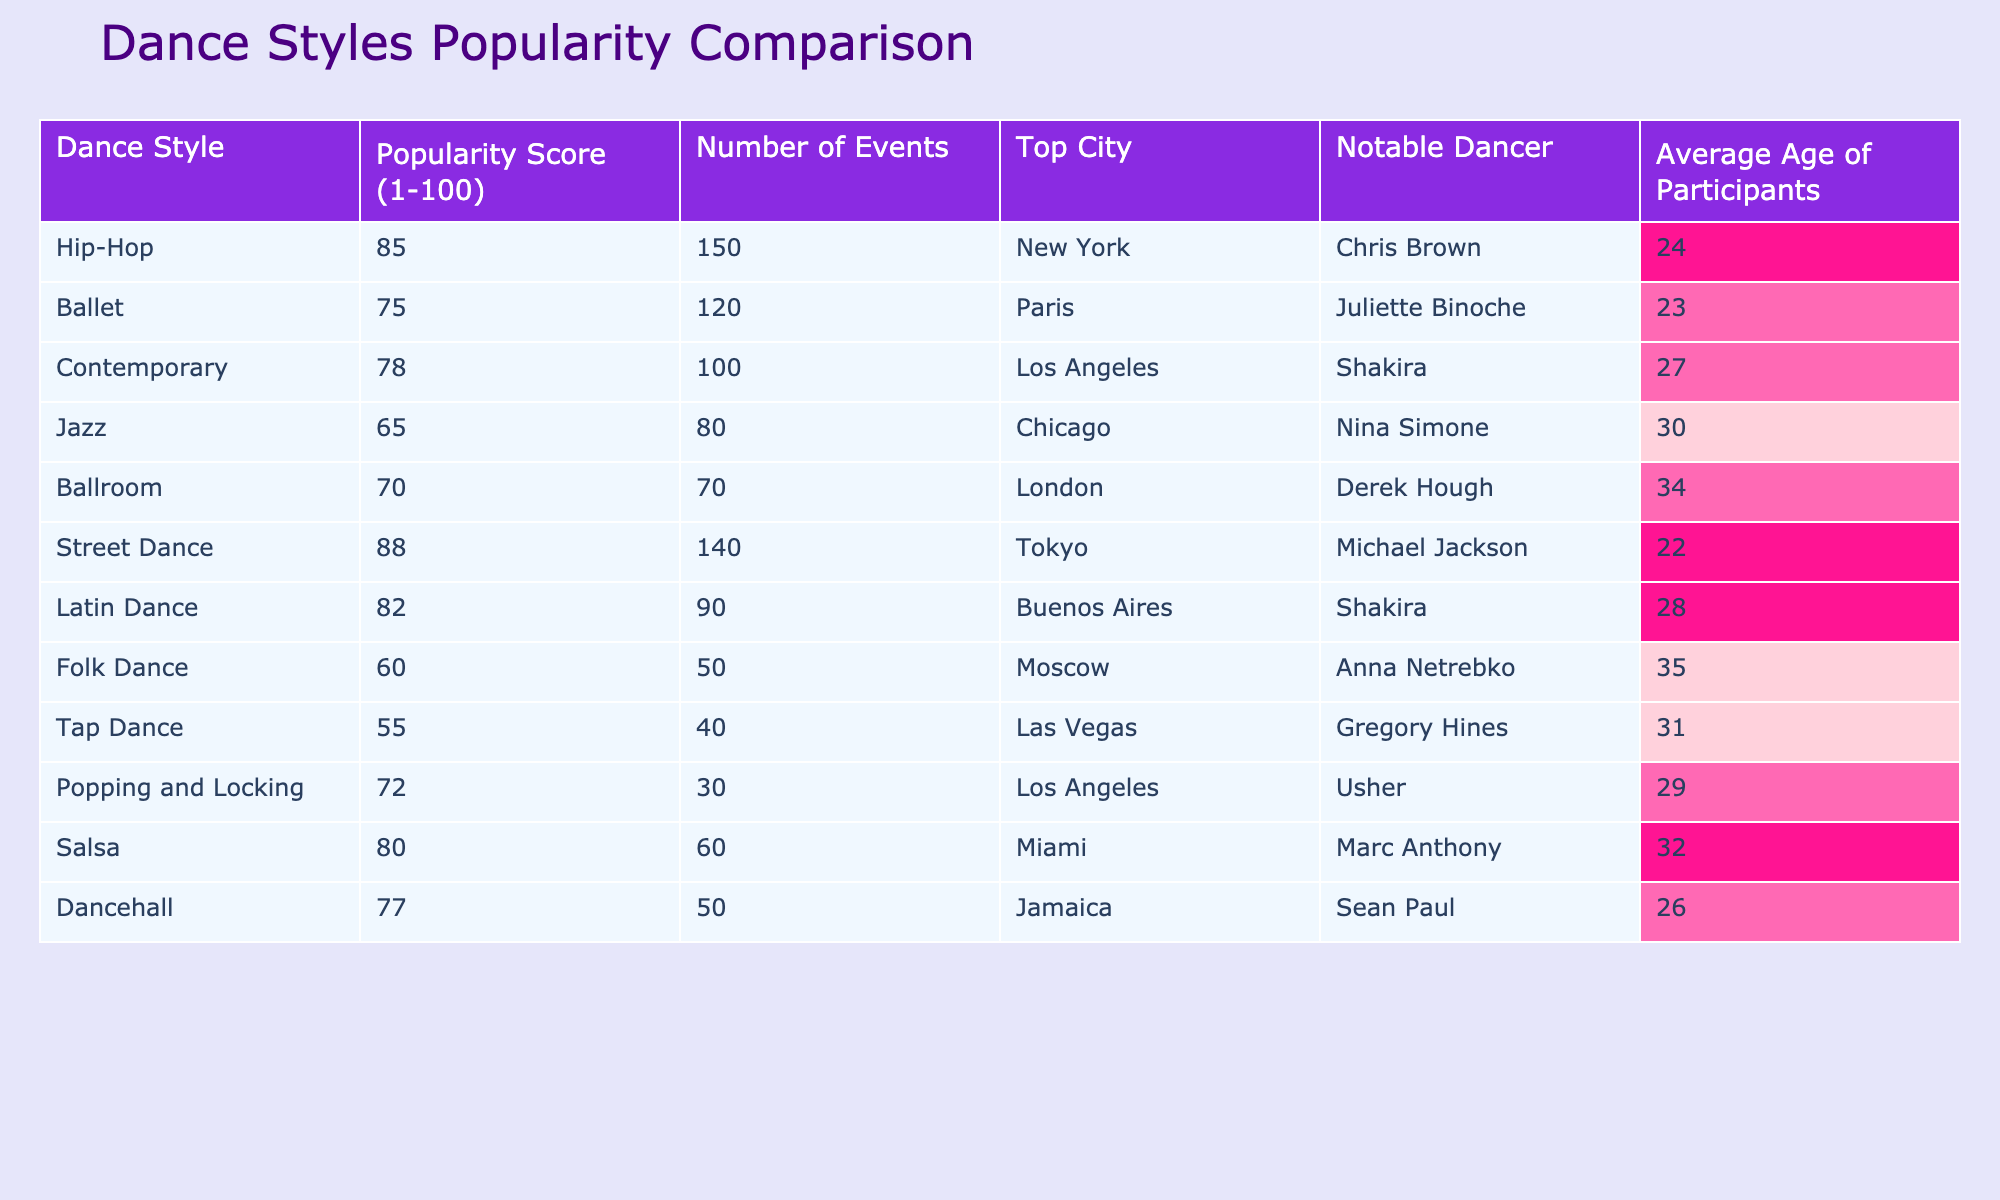What is the highest popularity score among the dance styles? The table shows a column for the "Popularity Score (1-100)" for each dance style. The highest value listed is for Hip-Hop, which has a score of 85.
Answer: 85 Which dance style has the most number of events? By examining the "Number of Events" column, I see that Hip-Hop has the highest count, with a total of 150 events organized.
Answer: Hip-Hop What is the average age of participants in Contemporary dance? Looking at the "Average Age of Participants" column, the age listed for Contemporary dance is 27.
Answer: 27 Is there a dance style with a popularity score below 60? The "Popularity Score (1-100)" column shows scores for all styles, and Folk Dance is the only style with a score of 60, which is right at the threshold, but no styles fall below that score.
Answer: No Which dance style is the top choice in Buenos Aires? The table indicates that Latin Dance is the most popular style in Buenos Aires, as referenced in the "Top City" column for that style.
Answer: Latin Dance How many dance styles have a popularity score of 80 or higher? By reviewing the "Popularity Score" column, I find that Hip-Hop, Street Dance, Latin Dance, and Salsa all have scores of 80 or higher, making a total of four styles.
Answer: 4 Which city has the least number of events and what is its dance style? From the "Number of Events" column, Tap Dance, which has only 40 events, is the lowest, and it takes place in Las Vegas.
Answer: Las Vegas, Tap Dance What is the difference between the highest and lowest popularity scores? The highest score is for Hip-Hop (85), and the lowest is for Tap Dance (55). The difference is calculated by subtracting: 85 - 55 = 30.
Answer: 30 Which notable dancer is associated with the highest popularity score? The highest popularity score belongs to Hip-Hop, and its notable dancer is Chris Brown.
Answer: Chris Brown If we take the average of the popularity scores for all styles, what would it be? The scores listed are: 85, 75, 78, 65, 70, 88, 82, 60, 55, 72, 80, and 77. When summed, the total is  85 + 75 + 78 + 65 + 70 + 88 + 82 + 60 + 55 + 72 + 80 + 77 =  75.75. Dividing by the number of styles (12) gives an average of approximately 75.75.
Answer: 75.75 Which dance style has the oldest average age of participants and what is that age? By checking the "Average Age of Participants" column, the oldest average age is associated with Folk Dance, which has an average age of 35.
Answer: Folk Dance, 35 What two dance styles have the same number of events and what are they? Referring to the "Number of Events" column, both Ballroom and Folk Dance have the same count of 70 events.
Answer: Ballroom and Folk Dance 